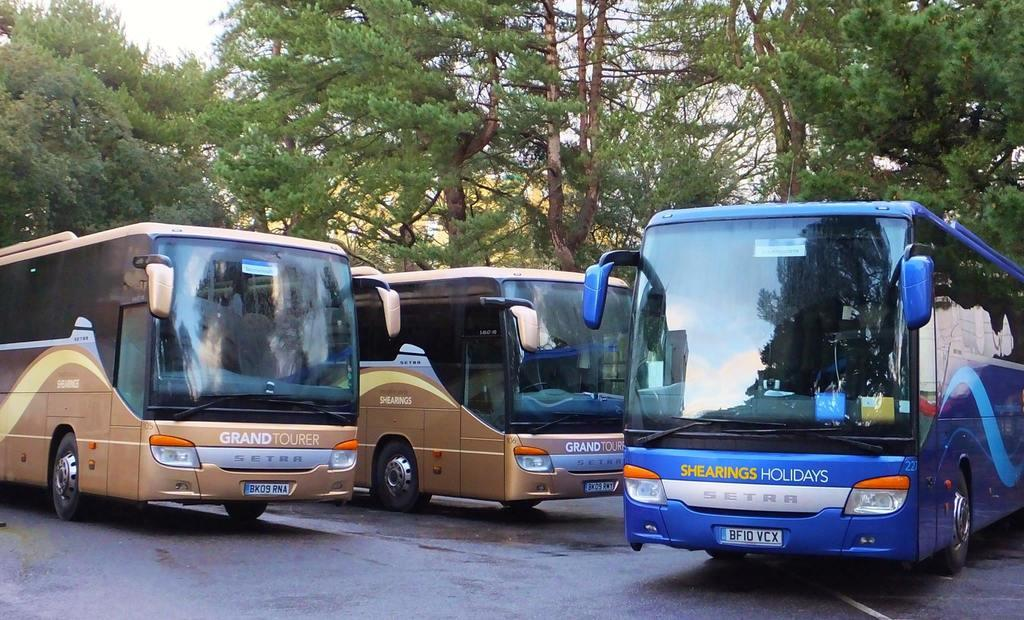What is the main subject of the image? The main subject of the image is buses. Where are the buses located in the image? The buses are on the road in the center of the image. What can be seen in the background of the image? There are trees and the sky visible in the background of the image. Can you see a match being lit in the image? There is no match or any indication of fire in the image. Is there any sign of death or a deceased person in the image? There is no indication of death or a deceased person in the image. 